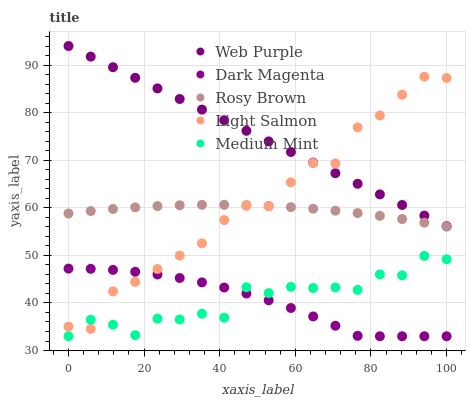Does Dark Magenta have the minimum area under the curve?
Answer yes or no. Yes. Does Web Purple have the maximum area under the curve?
Answer yes or no. Yes. Does Rosy Brown have the minimum area under the curve?
Answer yes or no. No. Does Rosy Brown have the maximum area under the curve?
Answer yes or no. No. Is Web Purple the smoothest?
Answer yes or no. Yes. Is Medium Mint the roughest?
Answer yes or no. Yes. Is Rosy Brown the smoothest?
Answer yes or no. No. Is Rosy Brown the roughest?
Answer yes or no. No. Does Medium Mint have the lowest value?
Answer yes or no. Yes. Does Rosy Brown have the lowest value?
Answer yes or no. No. Does Web Purple have the highest value?
Answer yes or no. Yes. Does Rosy Brown have the highest value?
Answer yes or no. No. Is Dark Magenta less than Web Purple?
Answer yes or no. Yes. Is Rosy Brown greater than Medium Mint?
Answer yes or no. Yes. Does Light Salmon intersect Web Purple?
Answer yes or no. Yes. Is Light Salmon less than Web Purple?
Answer yes or no. No. Is Light Salmon greater than Web Purple?
Answer yes or no. No. Does Dark Magenta intersect Web Purple?
Answer yes or no. No. 